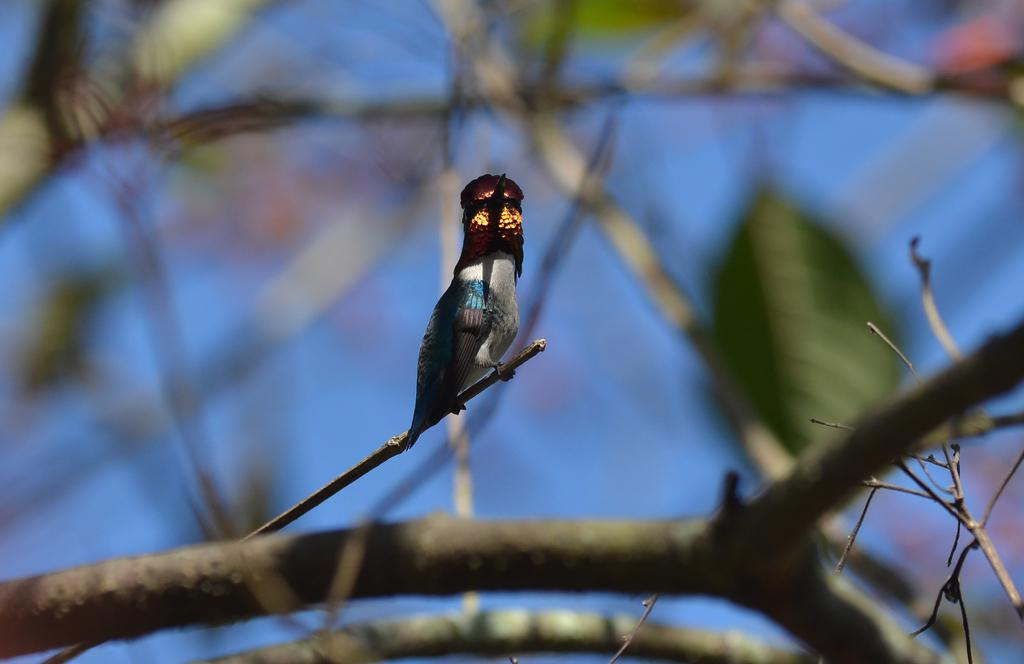What type of animal is in the image? There is a bird in the image. Where is the bird located? The bird is on a twig. Can you describe the background of the image? The background of the image is blurred. What type of flower is the bird wearing as apparel in the image? There is no flower or apparel present in the image; the bird is simply sitting on a twig. 